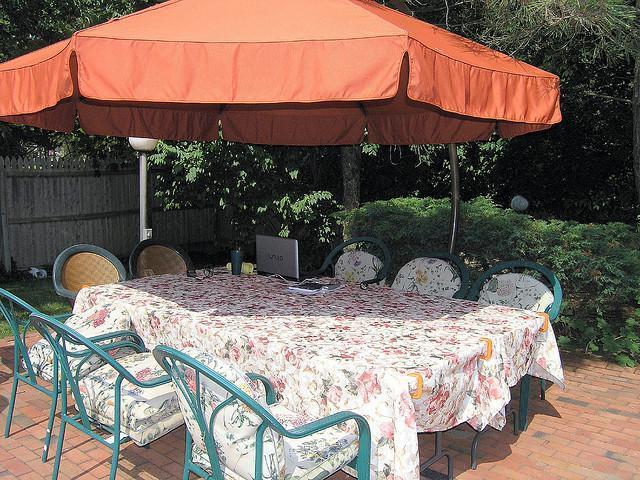How many chairs?
Give a very brief answer. 8. How many chairs can be seen?
Give a very brief answer. 8. 